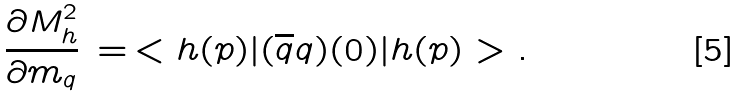Convert formula to latex. <formula><loc_0><loc_0><loc_500><loc_500>\frac { \partial M _ { h } ^ { 2 } } { \partial m _ { q } } \, = \, < h ( p ) | ( { \overline { q } } q ) ( 0 ) | h ( p ) > .</formula> 